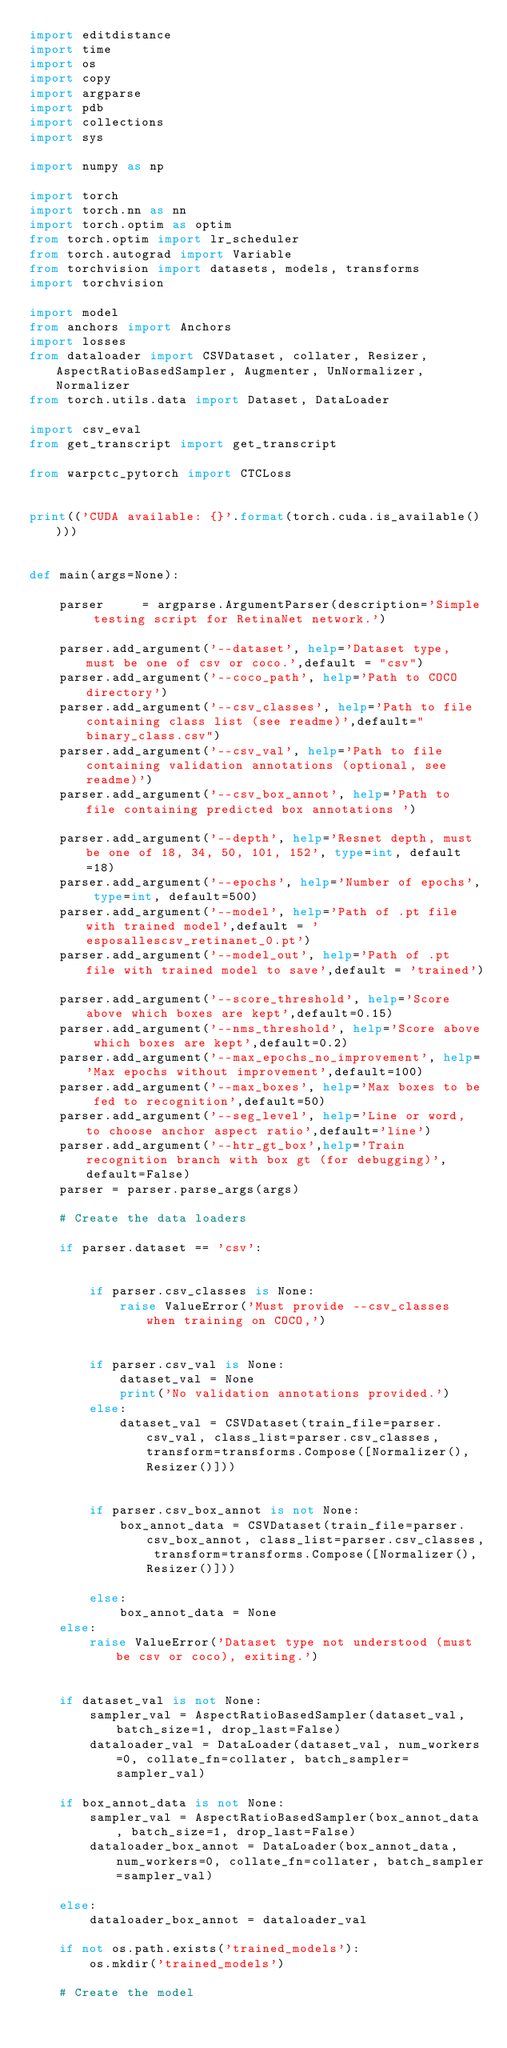<code> <loc_0><loc_0><loc_500><loc_500><_Python_>import editdistance
import time
import os
import copy
import argparse
import pdb
import collections
import sys

import numpy as np

import torch
import torch.nn as nn
import torch.optim as optim
from torch.optim import lr_scheduler
from torch.autograd import Variable
from torchvision import datasets, models, transforms
import torchvision

import model
from anchors import Anchors
import losses
from dataloader import CSVDataset, collater, Resizer, AspectRatioBasedSampler, Augmenter, UnNormalizer, Normalizer
from torch.utils.data import Dataset, DataLoader

import csv_eval
from get_transcript import get_transcript

from warpctc_pytorch import CTCLoss


print(('CUDA available: {}'.format(torch.cuda.is_available())))


def main(args=None):

    parser     = argparse.ArgumentParser(description='Simple testing script for RetinaNet network.')

    parser.add_argument('--dataset', help='Dataset type, must be one of csv or coco.',default = "csv")
    parser.add_argument('--coco_path', help='Path to COCO directory')
    parser.add_argument('--csv_classes', help='Path to file containing class list (see readme)',default="binary_class.csv")
    parser.add_argument('--csv_val', help='Path to file containing validation annotations (optional, see readme)')
    parser.add_argument('--csv_box_annot', help='Path to file containing predicted box annotations ')

    parser.add_argument('--depth', help='Resnet depth, must be one of 18, 34, 50, 101, 152', type=int, default=18)
    parser.add_argument('--epochs', help='Number of epochs', type=int, default=500)
    parser.add_argument('--model', help='Path of .pt file with trained model',default = 'esposallescsv_retinanet_0.pt')
    parser.add_argument('--model_out', help='Path of .pt file with trained model to save',default = 'trained')

    parser.add_argument('--score_threshold', help='Score above which boxes are kept',default=0.15)
    parser.add_argument('--nms_threshold', help='Score above which boxes are kept',default=0.2)
    parser.add_argument('--max_epochs_no_improvement', help='Max epochs without improvement',default=100)
    parser.add_argument('--max_boxes', help='Max boxes to be fed to recognition',default=50)
    parser.add_argument('--seg_level', help='Line or word, to choose anchor aspect ratio',default='line')
    parser.add_argument('--htr_gt_box',help='Train recognition branch with box gt (for debugging)',default=False)
    parser = parser.parse_args(args)
    
    # Create the data loaders

    if parser.dataset == 'csv':


        if parser.csv_classes is None:
            raise ValueError('Must provide --csv_classes when training on COCO,')


        if parser.csv_val is None:
            dataset_val = None
            print('No validation annotations provided.')
        else:
            dataset_val = CSVDataset(train_file=parser.csv_val, class_list=parser.csv_classes, transform=transforms.Compose([Normalizer(), Resizer()]))


        if parser.csv_box_annot is not None:
            box_annot_data = CSVDataset(train_file=parser.csv_box_annot, class_list=parser.csv_classes, transform=transforms.Compose([Normalizer(), Resizer()]))

        else:    
            box_annot_data = None
    else:
        raise ValueError('Dataset type not understood (must be csv or coco), exiting.')

    
    if dataset_val is not None:
        sampler_val = AspectRatioBasedSampler(dataset_val, batch_size=1, drop_last=False)
        dataloader_val = DataLoader(dataset_val, num_workers=0, collate_fn=collater, batch_sampler=sampler_val)

    if box_annot_data is not None:
        sampler_val = AspectRatioBasedSampler(box_annot_data, batch_size=1, drop_last=False)
        dataloader_box_annot = DataLoader(box_annot_data, num_workers=0, collate_fn=collater, batch_sampler=sampler_val)

    else:
        dataloader_box_annot = dataloader_val

    if not os.path.exists('trained_models'):
        os.mkdir('trained_models')

    # Create the model
</code> 